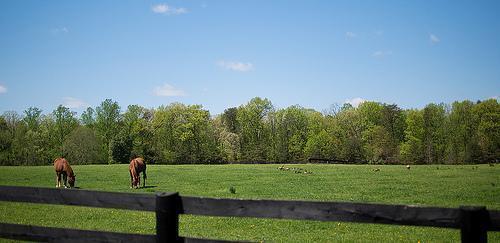How many horses are in the field?
Give a very brief answer. 2. 